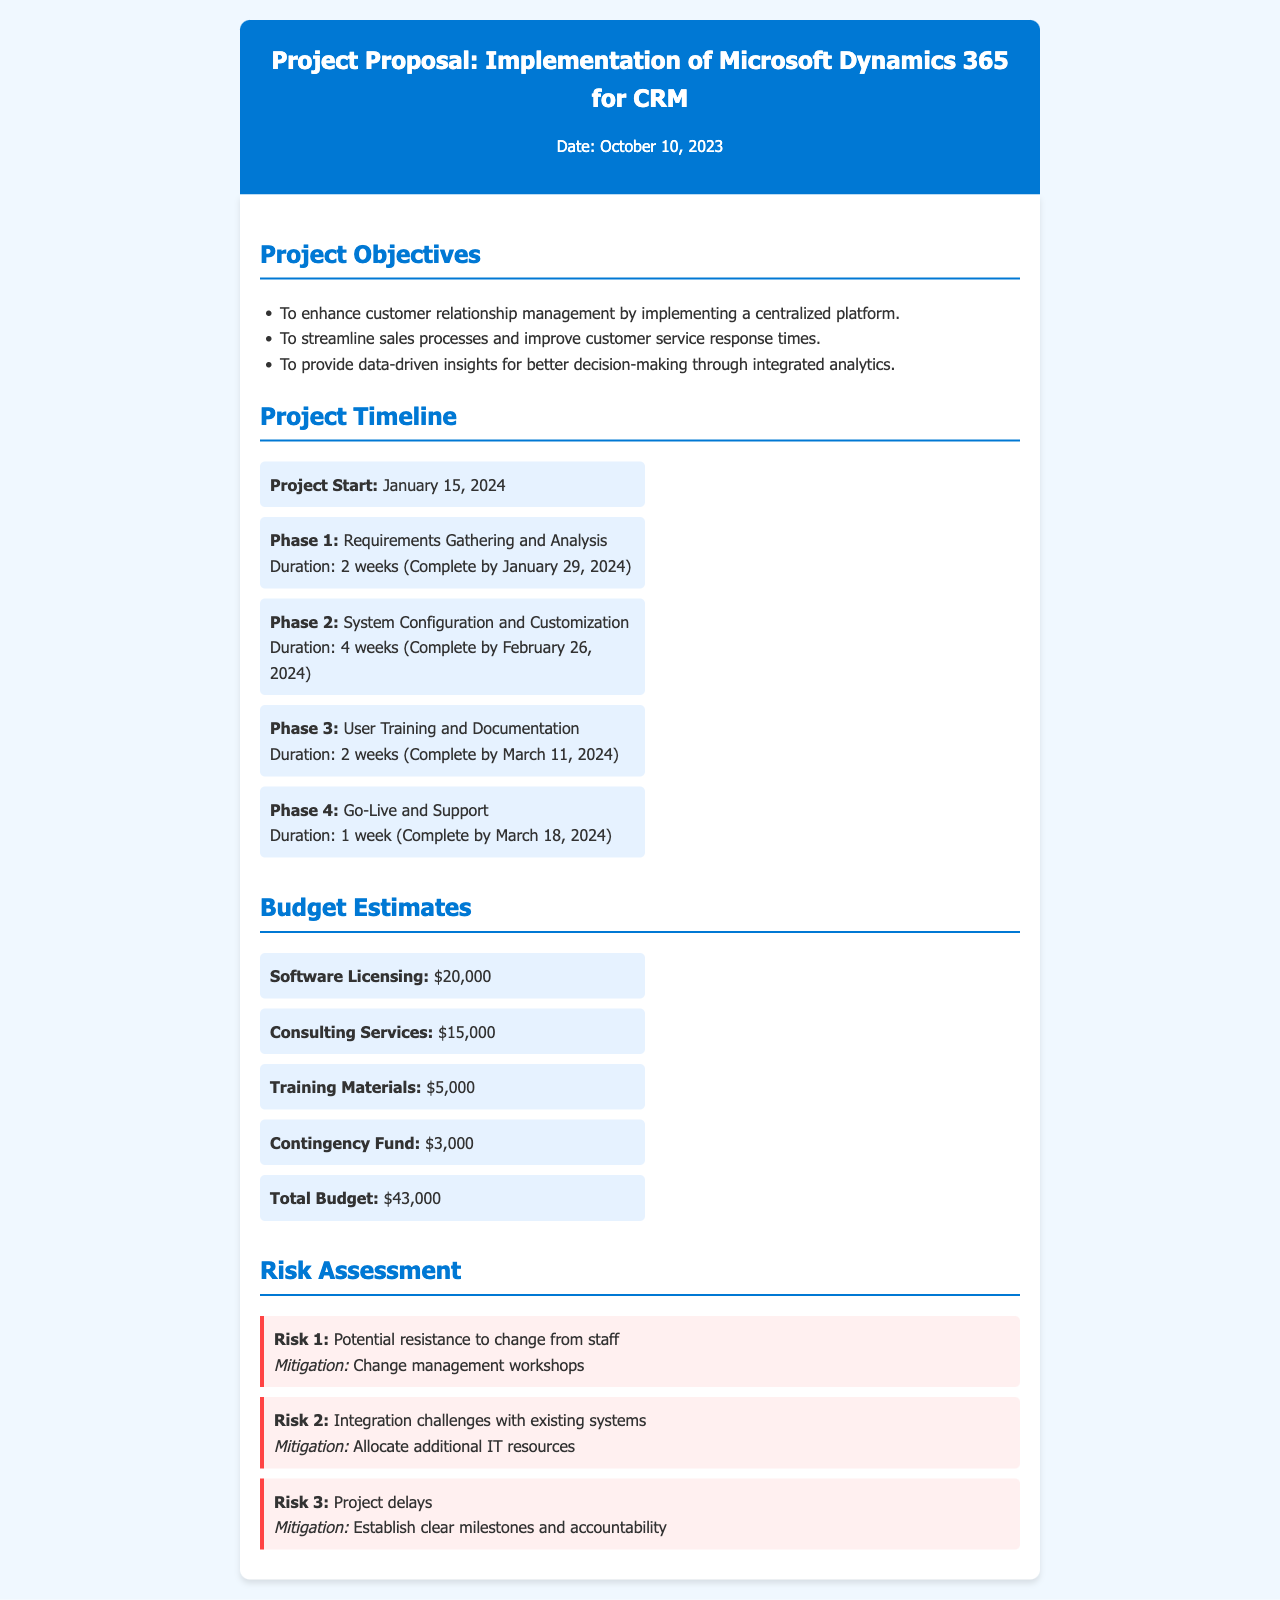What is the project start date? The project start date is explicitly mentioned as January 15, 2024 in the timeline section.
Answer: January 15, 2024 What is the total budget estimate? The total budget estimate is calculated from all budget items listed, clearly stated as $43,000.
Answer: $43,000 What is the duration of Phase 2? The duration of Phase 2 is specified as 4 weeks in the timeline.
Answer: 4 weeks What is one of the project objectives? The document lists multiple objectives, one being to enhance customer relationship management through a centralized platform.
Answer: Enhance customer relationship management What is a risk associated with the project? Risks are outlined, including potential resistance to change from staff.
Answer: Potential resistance to change from staff When is the completion date for User Training and Documentation? This information is provided in the timeline under Phase 3, completing by March 11, 2024.
Answer: March 11, 2024 How much is allocated for training materials? The budget section specifies that $5,000 is allocated for training materials.
Answer: $5,000 What phase follows User Training and Documentation? According to the timeline, the phase that follows is Go-Live and Support.
Answer: Go-Live and Support How long will the Go-Live and Support phase last? The document indicates that this phase will last for 1 week.
Answer: 1 week 